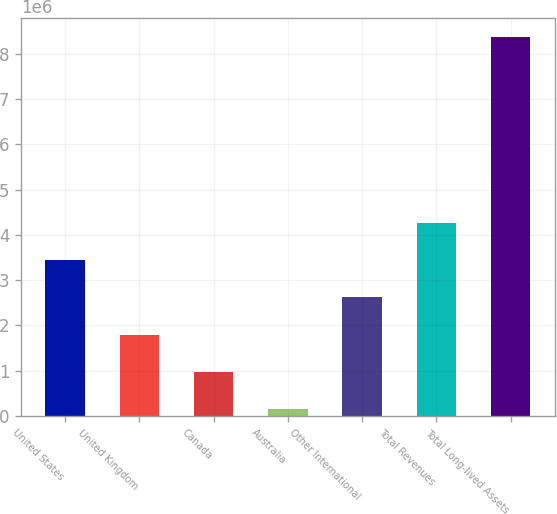Convert chart. <chart><loc_0><loc_0><loc_500><loc_500><bar_chart><fcel>United States<fcel>United Kingdom<fcel>Canada<fcel>Australia<fcel>Other International<fcel>Total Revenues<fcel>Total Long-lived Assets<nl><fcel>3.43878e+06<fcel>1.79348e+06<fcel>970827<fcel>148175<fcel>2.61613e+06<fcel>4.26143e+06<fcel>8.37469e+06<nl></chart> 